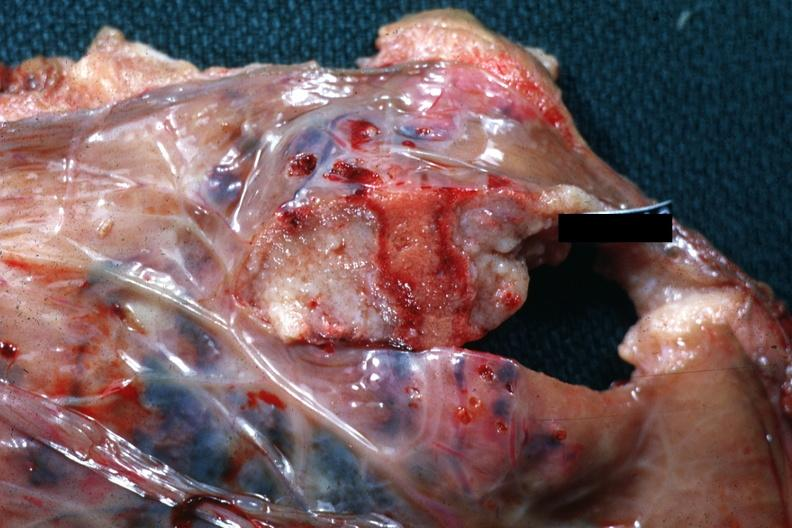how does this image show good close-up of needle tract?
Answer the question using a single word or phrase. With necrotic center 